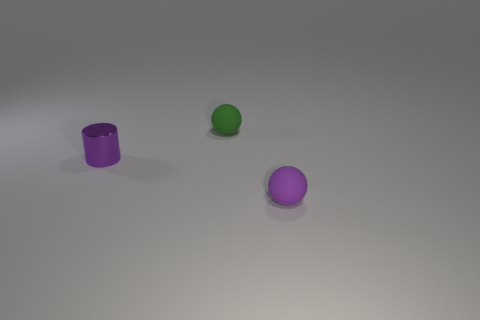Add 1 matte things. How many objects exist? 4 Subtract 0 brown blocks. How many objects are left? 3 Subtract all balls. How many objects are left? 1 Subtract all blocks. Subtract all shiny objects. How many objects are left? 2 Add 3 tiny things. How many tiny things are left? 6 Add 3 metal objects. How many metal objects exist? 4 